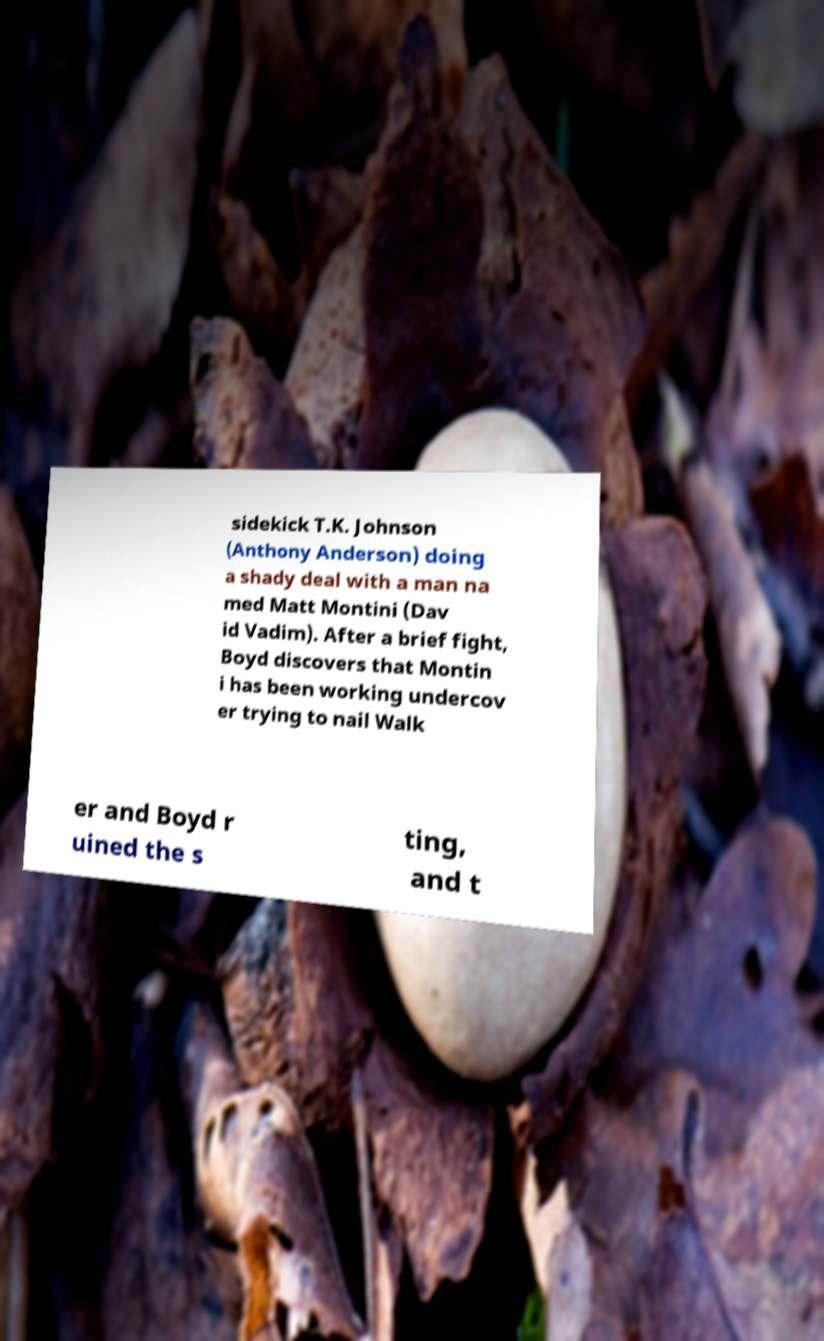Can you read and provide the text displayed in the image?This photo seems to have some interesting text. Can you extract and type it out for me? sidekick T.K. Johnson (Anthony Anderson) doing a shady deal with a man na med Matt Montini (Dav id Vadim). After a brief fight, Boyd discovers that Montin i has been working undercov er trying to nail Walk er and Boyd r uined the s ting, and t 